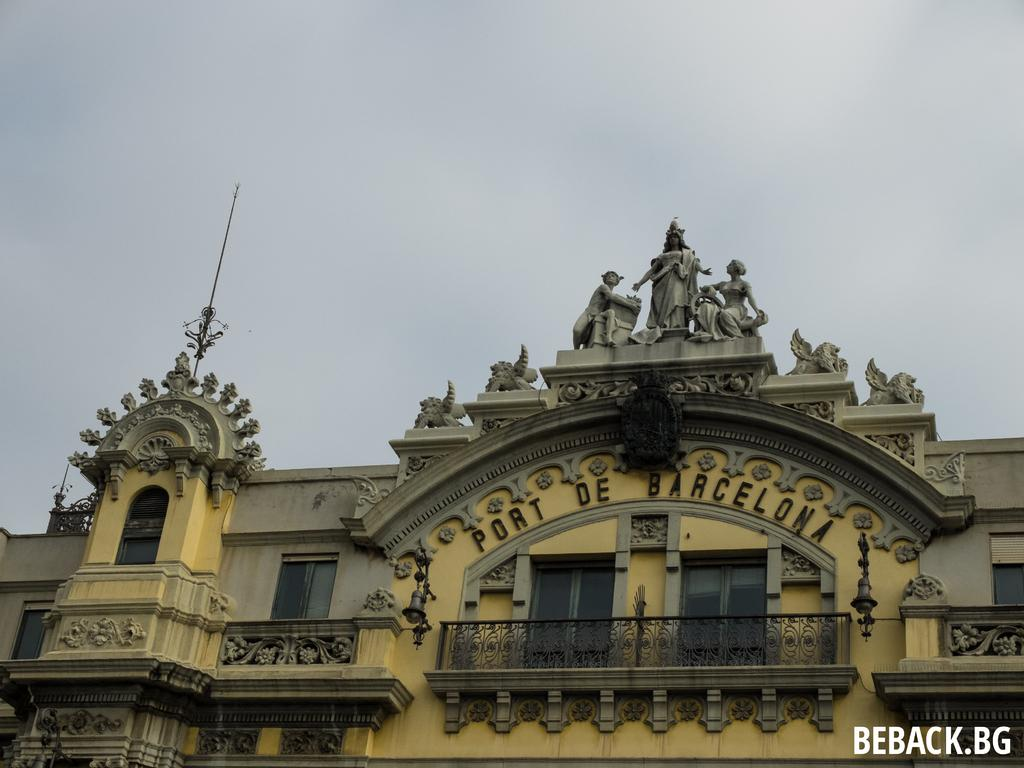Provide a one-sentence caption for the provided image. Large yellow building with Port De Barcelona on the front. 